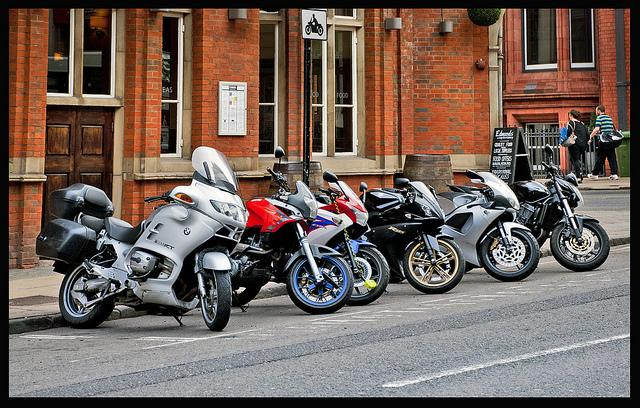What are bricks mostly made of? Please explain your reasoning. clay. The bricks are made of clay. 